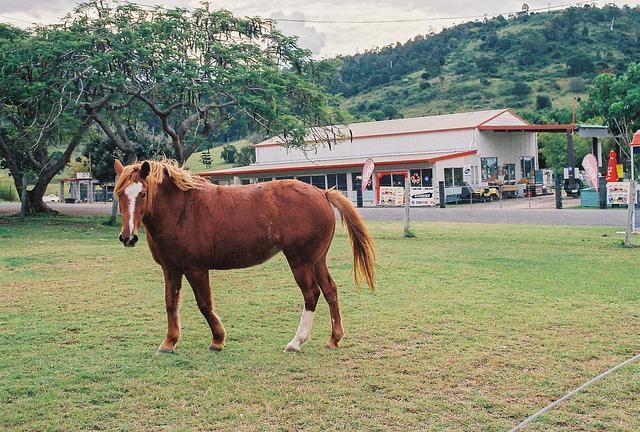How many white feet?
Give a very brief answer. 1. How many horses are visible?
Give a very brief answer. 1. 